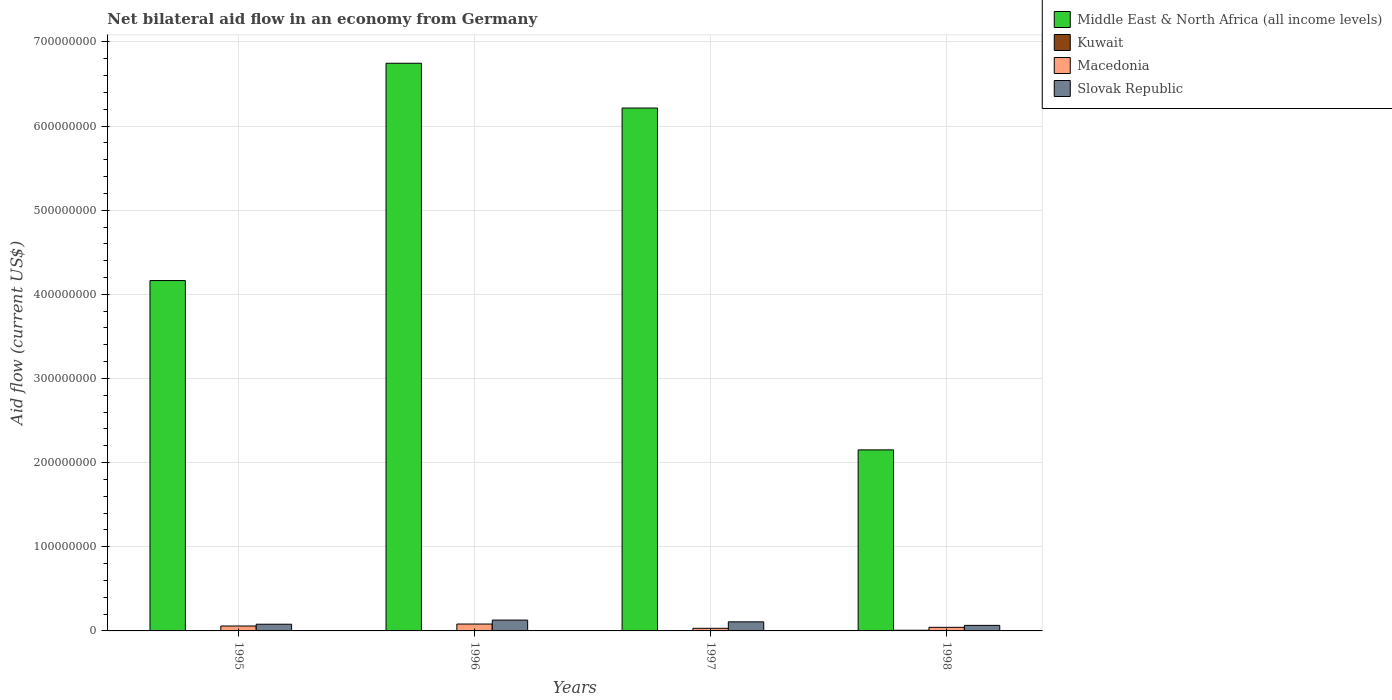Are the number of bars on each tick of the X-axis equal?
Make the answer very short. Yes. What is the net bilateral aid flow in Slovak Republic in 1998?
Offer a very short reply. 6.58e+06. Across all years, what is the maximum net bilateral aid flow in Slovak Republic?
Provide a succinct answer. 1.29e+07. Across all years, what is the minimum net bilateral aid flow in Middle East & North Africa (all income levels)?
Ensure brevity in your answer.  2.15e+08. What is the total net bilateral aid flow in Slovak Republic in the graph?
Your answer should be compact. 3.82e+07. What is the difference between the net bilateral aid flow in Middle East & North Africa (all income levels) in 1997 and that in 1998?
Offer a very short reply. 4.06e+08. What is the difference between the net bilateral aid flow in Macedonia in 1998 and the net bilateral aid flow in Middle East & North Africa (all income levels) in 1996?
Offer a terse response. -6.70e+08. What is the average net bilateral aid flow in Middle East & North Africa (all income levels) per year?
Provide a succinct answer. 4.82e+08. In the year 1997, what is the difference between the net bilateral aid flow in Kuwait and net bilateral aid flow in Middle East & North Africa (all income levels)?
Keep it short and to the point. -6.21e+08. In how many years, is the net bilateral aid flow in Middle East & North Africa (all income levels) greater than 120000000 US$?
Offer a terse response. 4. What is the ratio of the net bilateral aid flow in Kuwait in 1995 to that in 1997?
Your answer should be compact. 1.25. Is the difference between the net bilateral aid flow in Kuwait in 1995 and 1998 greater than the difference between the net bilateral aid flow in Middle East & North Africa (all income levels) in 1995 and 1998?
Give a very brief answer. No. What is the difference between the highest and the second highest net bilateral aid flow in Macedonia?
Provide a short and direct response. 2.31e+06. What is the difference between the highest and the lowest net bilateral aid flow in Middle East & North Africa (all income levels)?
Offer a terse response. 4.59e+08. What does the 1st bar from the left in 1998 represents?
Provide a succinct answer. Middle East & North Africa (all income levels). What does the 3rd bar from the right in 1995 represents?
Keep it short and to the point. Kuwait. Is it the case that in every year, the sum of the net bilateral aid flow in Middle East & North Africa (all income levels) and net bilateral aid flow in Kuwait is greater than the net bilateral aid flow in Slovak Republic?
Your answer should be very brief. Yes. How many years are there in the graph?
Offer a very short reply. 4. What is the difference between two consecutive major ticks on the Y-axis?
Provide a short and direct response. 1.00e+08. Are the values on the major ticks of Y-axis written in scientific E-notation?
Provide a short and direct response. No. How are the legend labels stacked?
Make the answer very short. Vertical. What is the title of the graph?
Your response must be concise. Net bilateral aid flow in an economy from Germany. What is the label or title of the X-axis?
Your response must be concise. Years. What is the label or title of the Y-axis?
Your answer should be compact. Aid flow (current US$). What is the Aid flow (current US$) of Middle East & North Africa (all income levels) in 1995?
Give a very brief answer. 4.16e+08. What is the Aid flow (current US$) of Kuwait in 1995?
Provide a short and direct response. 1.50e+05. What is the Aid flow (current US$) in Macedonia in 1995?
Provide a short and direct response. 5.86e+06. What is the Aid flow (current US$) of Slovak Republic in 1995?
Offer a very short reply. 7.96e+06. What is the Aid flow (current US$) in Middle East & North Africa (all income levels) in 1996?
Make the answer very short. 6.75e+08. What is the Aid flow (current US$) of Macedonia in 1996?
Offer a very short reply. 8.17e+06. What is the Aid flow (current US$) of Slovak Republic in 1996?
Provide a succinct answer. 1.29e+07. What is the Aid flow (current US$) of Middle East & North Africa (all income levels) in 1997?
Offer a very short reply. 6.21e+08. What is the Aid flow (current US$) in Macedonia in 1997?
Your response must be concise. 3.11e+06. What is the Aid flow (current US$) in Slovak Republic in 1997?
Make the answer very short. 1.08e+07. What is the Aid flow (current US$) of Middle East & North Africa (all income levels) in 1998?
Give a very brief answer. 2.15e+08. What is the Aid flow (current US$) of Macedonia in 1998?
Offer a very short reply. 4.27e+06. What is the Aid flow (current US$) in Slovak Republic in 1998?
Ensure brevity in your answer.  6.58e+06. Across all years, what is the maximum Aid flow (current US$) in Middle East & North Africa (all income levels)?
Make the answer very short. 6.75e+08. Across all years, what is the maximum Aid flow (current US$) in Macedonia?
Offer a very short reply. 8.17e+06. Across all years, what is the maximum Aid flow (current US$) of Slovak Republic?
Keep it short and to the point. 1.29e+07. Across all years, what is the minimum Aid flow (current US$) in Middle East & North Africa (all income levels)?
Offer a terse response. 2.15e+08. Across all years, what is the minimum Aid flow (current US$) in Macedonia?
Ensure brevity in your answer.  3.11e+06. Across all years, what is the minimum Aid flow (current US$) of Slovak Republic?
Provide a short and direct response. 6.58e+06. What is the total Aid flow (current US$) of Middle East & North Africa (all income levels) in the graph?
Ensure brevity in your answer.  1.93e+09. What is the total Aid flow (current US$) in Kuwait in the graph?
Your answer should be very brief. 1.21e+06. What is the total Aid flow (current US$) of Macedonia in the graph?
Provide a short and direct response. 2.14e+07. What is the total Aid flow (current US$) in Slovak Republic in the graph?
Your response must be concise. 3.82e+07. What is the difference between the Aid flow (current US$) of Middle East & North Africa (all income levels) in 1995 and that in 1996?
Your answer should be very brief. -2.58e+08. What is the difference between the Aid flow (current US$) in Macedonia in 1995 and that in 1996?
Your response must be concise. -2.31e+06. What is the difference between the Aid flow (current US$) of Slovak Republic in 1995 and that in 1996?
Provide a succinct answer. -4.92e+06. What is the difference between the Aid flow (current US$) of Middle East & North Africa (all income levels) in 1995 and that in 1997?
Keep it short and to the point. -2.05e+08. What is the difference between the Aid flow (current US$) in Kuwait in 1995 and that in 1997?
Provide a short and direct response. 3.00e+04. What is the difference between the Aid flow (current US$) in Macedonia in 1995 and that in 1997?
Provide a succinct answer. 2.75e+06. What is the difference between the Aid flow (current US$) of Slovak Republic in 1995 and that in 1997?
Offer a terse response. -2.84e+06. What is the difference between the Aid flow (current US$) in Middle East & North Africa (all income levels) in 1995 and that in 1998?
Your response must be concise. 2.01e+08. What is the difference between the Aid flow (current US$) in Kuwait in 1995 and that in 1998?
Offer a terse response. -6.50e+05. What is the difference between the Aid flow (current US$) in Macedonia in 1995 and that in 1998?
Offer a terse response. 1.59e+06. What is the difference between the Aid flow (current US$) in Slovak Republic in 1995 and that in 1998?
Give a very brief answer. 1.38e+06. What is the difference between the Aid flow (current US$) in Middle East & North Africa (all income levels) in 1996 and that in 1997?
Provide a short and direct response. 5.32e+07. What is the difference between the Aid flow (current US$) in Macedonia in 1996 and that in 1997?
Make the answer very short. 5.06e+06. What is the difference between the Aid flow (current US$) in Slovak Republic in 1996 and that in 1997?
Your response must be concise. 2.08e+06. What is the difference between the Aid flow (current US$) of Middle East & North Africa (all income levels) in 1996 and that in 1998?
Your answer should be very brief. 4.59e+08. What is the difference between the Aid flow (current US$) in Kuwait in 1996 and that in 1998?
Offer a very short reply. -6.60e+05. What is the difference between the Aid flow (current US$) of Macedonia in 1996 and that in 1998?
Make the answer very short. 3.90e+06. What is the difference between the Aid flow (current US$) of Slovak Republic in 1996 and that in 1998?
Your answer should be compact. 6.30e+06. What is the difference between the Aid flow (current US$) of Middle East & North Africa (all income levels) in 1997 and that in 1998?
Your answer should be very brief. 4.06e+08. What is the difference between the Aid flow (current US$) in Kuwait in 1997 and that in 1998?
Provide a succinct answer. -6.80e+05. What is the difference between the Aid flow (current US$) in Macedonia in 1997 and that in 1998?
Offer a terse response. -1.16e+06. What is the difference between the Aid flow (current US$) in Slovak Republic in 1997 and that in 1998?
Ensure brevity in your answer.  4.22e+06. What is the difference between the Aid flow (current US$) in Middle East & North Africa (all income levels) in 1995 and the Aid flow (current US$) in Kuwait in 1996?
Provide a short and direct response. 4.16e+08. What is the difference between the Aid flow (current US$) in Middle East & North Africa (all income levels) in 1995 and the Aid flow (current US$) in Macedonia in 1996?
Provide a short and direct response. 4.08e+08. What is the difference between the Aid flow (current US$) of Middle East & North Africa (all income levels) in 1995 and the Aid flow (current US$) of Slovak Republic in 1996?
Your answer should be compact. 4.03e+08. What is the difference between the Aid flow (current US$) of Kuwait in 1995 and the Aid flow (current US$) of Macedonia in 1996?
Make the answer very short. -8.02e+06. What is the difference between the Aid flow (current US$) in Kuwait in 1995 and the Aid flow (current US$) in Slovak Republic in 1996?
Provide a succinct answer. -1.27e+07. What is the difference between the Aid flow (current US$) in Macedonia in 1995 and the Aid flow (current US$) in Slovak Republic in 1996?
Your response must be concise. -7.02e+06. What is the difference between the Aid flow (current US$) of Middle East & North Africa (all income levels) in 1995 and the Aid flow (current US$) of Kuwait in 1997?
Your answer should be very brief. 4.16e+08. What is the difference between the Aid flow (current US$) in Middle East & North Africa (all income levels) in 1995 and the Aid flow (current US$) in Macedonia in 1997?
Your answer should be very brief. 4.13e+08. What is the difference between the Aid flow (current US$) in Middle East & North Africa (all income levels) in 1995 and the Aid flow (current US$) in Slovak Republic in 1997?
Your response must be concise. 4.06e+08. What is the difference between the Aid flow (current US$) of Kuwait in 1995 and the Aid flow (current US$) of Macedonia in 1997?
Your answer should be very brief. -2.96e+06. What is the difference between the Aid flow (current US$) in Kuwait in 1995 and the Aid flow (current US$) in Slovak Republic in 1997?
Provide a short and direct response. -1.06e+07. What is the difference between the Aid flow (current US$) of Macedonia in 1995 and the Aid flow (current US$) of Slovak Republic in 1997?
Your response must be concise. -4.94e+06. What is the difference between the Aid flow (current US$) in Middle East & North Africa (all income levels) in 1995 and the Aid flow (current US$) in Kuwait in 1998?
Your answer should be very brief. 4.16e+08. What is the difference between the Aid flow (current US$) in Middle East & North Africa (all income levels) in 1995 and the Aid flow (current US$) in Macedonia in 1998?
Your answer should be compact. 4.12e+08. What is the difference between the Aid flow (current US$) in Middle East & North Africa (all income levels) in 1995 and the Aid flow (current US$) in Slovak Republic in 1998?
Provide a succinct answer. 4.10e+08. What is the difference between the Aid flow (current US$) in Kuwait in 1995 and the Aid flow (current US$) in Macedonia in 1998?
Ensure brevity in your answer.  -4.12e+06. What is the difference between the Aid flow (current US$) of Kuwait in 1995 and the Aid flow (current US$) of Slovak Republic in 1998?
Keep it short and to the point. -6.43e+06. What is the difference between the Aid flow (current US$) of Macedonia in 1995 and the Aid flow (current US$) of Slovak Republic in 1998?
Provide a short and direct response. -7.20e+05. What is the difference between the Aid flow (current US$) in Middle East & North Africa (all income levels) in 1996 and the Aid flow (current US$) in Kuwait in 1997?
Ensure brevity in your answer.  6.74e+08. What is the difference between the Aid flow (current US$) in Middle East & North Africa (all income levels) in 1996 and the Aid flow (current US$) in Macedonia in 1997?
Your answer should be very brief. 6.71e+08. What is the difference between the Aid flow (current US$) in Middle East & North Africa (all income levels) in 1996 and the Aid flow (current US$) in Slovak Republic in 1997?
Your answer should be compact. 6.64e+08. What is the difference between the Aid flow (current US$) in Kuwait in 1996 and the Aid flow (current US$) in Macedonia in 1997?
Your answer should be compact. -2.97e+06. What is the difference between the Aid flow (current US$) of Kuwait in 1996 and the Aid flow (current US$) of Slovak Republic in 1997?
Your response must be concise. -1.07e+07. What is the difference between the Aid flow (current US$) of Macedonia in 1996 and the Aid flow (current US$) of Slovak Republic in 1997?
Your response must be concise. -2.63e+06. What is the difference between the Aid flow (current US$) of Middle East & North Africa (all income levels) in 1996 and the Aid flow (current US$) of Kuwait in 1998?
Your answer should be very brief. 6.74e+08. What is the difference between the Aid flow (current US$) in Middle East & North Africa (all income levels) in 1996 and the Aid flow (current US$) in Macedonia in 1998?
Your answer should be compact. 6.70e+08. What is the difference between the Aid flow (current US$) of Middle East & North Africa (all income levels) in 1996 and the Aid flow (current US$) of Slovak Republic in 1998?
Your answer should be compact. 6.68e+08. What is the difference between the Aid flow (current US$) in Kuwait in 1996 and the Aid flow (current US$) in Macedonia in 1998?
Your answer should be compact. -4.13e+06. What is the difference between the Aid flow (current US$) of Kuwait in 1996 and the Aid flow (current US$) of Slovak Republic in 1998?
Ensure brevity in your answer.  -6.44e+06. What is the difference between the Aid flow (current US$) in Macedonia in 1996 and the Aid flow (current US$) in Slovak Republic in 1998?
Make the answer very short. 1.59e+06. What is the difference between the Aid flow (current US$) of Middle East & North Africa (all income levels) in 1997 and the Aid flow (current US$) of Kuwait in 1998?
Your answer should be compact. 6.21e+08. What is the difference between the Aid flow (current US$) in Middle East & North Africa (all income levels) in 1997 and the Aid flow (current US$) in Macedonia in 1998?
Offer a very short reply. 6.17e+08. What is the difference between the Aid flow (current US$) of Middle East & North Africa (all income levels) in 1997 and the Aid flow (current US$) of Slovak Republic in 1998?
Your answer should be compact. 6.15e+08. What is the difference between the Aid flow (current US$) of Kuwait in 1997 and the Aid flow (current US$) of Macedonia in 1998?
Keep it short and to the point. -4.15e+06. What is the difference between the Aid flow (current US$) of Kuwait in 1997 and the Aid flow (current US$) of Slovak Republic in 1998?
Offer a very short reply. -6.46e+06. What is the difference between the Aid flow (current US$) in Macedonia in 1997 and the Aid flow (current US$) in Slovak Republic in 1998?
Keep it short and to the point. -3.47e+06. What is the average Aid flow (current US$) in Middle East & North Africa (all income levels) per year?
Your response must be concise. 4.82e+08. What is the average Aid flow (current US$) in Kuwait per year?
Offer a very short reply. 3.02e+05. What is the average Aid flow (current US$) in Macedonia per year?
Provide a succinct answer. 5.35e+06. What is the average Aid flow (current US$) in Slovak Republic per year?
Make the answer very short. 9.56e+06. In the year 1995, what is the difference between the Aid flow (current US$) in Middle East & North Africa (all income levels) and Aid flow (current US$) in Kuwait?
Provide a short and direct response. 4.16e+08. In the year 1995, what is the difference between the Aid flow (current US$) in Middle East & North Africa (all income levels) and Aid flow (current US$) in Macedonia?
Give a very brief answer. 4.10e+08. In the year 1995, what is the difference between the Aid flow (current US$) in Middle East & North Africa (all income levels) and Aid flow (current US$) in Slovak Republic?
Offer a terse response. 4.08e+08. In the year 1995, what is the difference between the Aid flow (current US$) in Kuwait and Aid flow (current US$) in Macedonia?
Offer a terse response. -5.71e+06. In the year 1995, what is the difference between the Aid flow (current US$) in Kuwait and Aid flow (current US$) in Slovak Republic?
Provide a succinct answer. -7.81e+06. In the year 1995, what is the difference between the Aid flow (current US$) in Macedonia and Aid flow (current US$) in Slovak Republic?
Provide a short and direct response. -2.10e+06. In the year 1996, what is the difference between the Aid flow (current US$) of Middle East & North Africa (all income levels) and Aid flow (current US$) of Kuwait?
Ensure brevity in your answer.  6.74e+08. In the year 1996, what is the difference between the Aid flow (current US$) of Middle East & North Africa (all income levels) and Aid flow (current US$) of Macedonia?
Give a very brief answer. 6.66e+08. In the year 1996, what is the difference between the Aid flow (current US$) in Middle East & North Africa (all income levels) and Aid flow (current US$) in Slovak Republic?
Provide a short and direct response. 6.62e+08. In the year 1996, what is the difference between the Aid flow (current US$) of Kuwait and Aid flow (current US$) of Macedonia?
Your answer should be very brief. -8.03e+06. In the year 1996, what is the difference between the Aid flow (current US$) in Kuwait and Aid flow (current US$) in Slovak Republic?
Give a very brief answer. -1.27e+07. In the year 1996, what is the difference between the Aid flow (current US$) of Macedonia and Aid flow (current US$) of Slovak Republic?
Provide a short and direct response. -4.71e+06. In the year 1997, what is the difference between the Aid flow (current US$) of Middle East & North Africa (all income levels) and Aid flow (current US$) of Kuwait?
Your answer should be very brief. 6.21e+08. In the year 1997, what is the difference between the Aid flow (current US$) in Middle East & North Africa (all income levels) and Aid flow (current US$) in Macedonia?
Provide a short and direct response. 6.18e+08. In the year 1997, what is the difference between the Aid flow (current US$) in Middle East & North Africa (all income levels) and Aid flow (current US$) in Slovak Republic?
Your answer should be very brief. 6.11e+08. In the year 1997, what is the difference between the Aid flow (current US$) in Kuwait and Aid flow (current US$) in Macedonia?
Provide a short and direct response. -2.99e+06. In the year 1997, what is the difference between the Aid flow (current US$) in Kuwait and Aid flow (current US$) in Slovak Republic?
Make the answer very short. -1.07e+07. In the year 1997, what is the difference between the Aid flow (current US$) in Macedonia and Aid flow (current US$) in Slovak Republic?
Your answer should be very brief. -7.69e+06. In the year 1998, what is the difference between the Aid flow (current US$) in Middle East & North Africa (all income levels) and Aid flow (current US$) in Kuwait?
Your answer should be very brief. 2.14e+08. In the year 1998, what is the difference between the Aid flow (current US$) of Middle East & North Africa (all income levels) and Aid flow (current US$) of Macedonia?
Keep it short and to the point. 2.11e+08. In the year 1998, what is the difference between the Aid flow (current US$) in Middle East & North Africa (all income levels) and Aid flow (current US$) in Slovak Republic?
Give a very brief answer. 2.09e+08. In the year 1998, what is the difference between the Aid flow (current US$) of Kuwait and Aid flow (current US$) of Macedonia?
Keep it short and to the point. -3.47e+06. In the year 1998, what is the difference between the Aid flow (current US$) in Kuwait and Aid flow (current US$) in Slovak Republic?
Give a very brief answer. -5.78e+06. In the year 1998, what is the difference between the Aid flow (current US$) of Macedonia and Aid flow (current US$) of Slovak Republic?
Offer a very short reply. -2.31e+06. What is the ratio of the Aid flow (current US$) in Middle East & North Africa (all income levels) in 1995 to that in 1996?
Provide a succinct answer. 0.62. What is the ratio of the Aid flow (current US$) of Kuwait in 1995 to that in 1996?
Make the answer very short. 1.07. What is the ratio of the Aid flow (current US$) in Macedonia in 1995 to that in 1996?
Give a very brief answer. 0.72. What is the ratio of the Aid flow (current US$) of Slovak Republic in 1995 to that in 1996?
Make the answer very short. 0.62. What is the ratio of the Aid flow (current US$) in Middle East & North Africa (all income levels) in 1995 to that in 1997?
Make the answer very short. 0.67. What is the ratio of the Aid flow (current US$) in Kuwait in 1995 to that in 1997?
Keep it short and to the point. 1.25. What is the ratio of the Aid flow (current US$) of Macedonia in 1995 to that in 1997?
Keep it short and to the point. 1.88. What is the ratio of the Aid flow (current US$) of Slovak Republic in 1995 to that in 1997?
Make the answer very short. 0.74. What is the ratio of the Aid flow (current US$) in Middle East & North Africa (all income levels) in 1995 to that in 1998?
Make the answer very short. 1.94. What is the ratio of the Aid flow (current US$) in Kuwait in 1995 to that in 1998?
Your answer should be very brief. 0.19. What is the ratio of the Aid flow (current US$) in Macedonia in 1995 to that in 1998?
Give a very brief answer. 1.37. What is the ratio of the Aid flow (current US$) of Slovak Republic in 1995 to that in 1998?
Offer a very short reply. 1.21. What is the ratio of the Aid flow (current US$) in Middle East & North Africa (all income levels) in 1996 to that in 1997?
Offer a terse response. 1.09. What is the ratio of the Aid flow (current US$) of Macedonia in 1996 to that in 1997?
Give a very brief answer. 2.63. What is the ratio of the Aid flow (current US$) in Slovak Republic in 1996 to that in 1997?
Offer a terse response. 1.19. What is the ratio of the Aid flow (current US$) of Middle East & North Africa (all income levels) in 1996 to that in 1998?
Make the answer very short. 3.14. What is the ratio of the Aid flow (current US$) in Kuwait in 1996 to that in 1998?
Keep it short and to the point. 0.17. What is the ratio of the Aid flow (current US$) in Macedonia in 1996 to that in 1998?
Make the answer very short. 1.91. What is the ratio of the Aid flow (current US$) of Slovak Republic in 1996 to that in 1998?
Provide a short and direct response. 1.96. What is the ratio of the Aid flow (current US$) in Middle East & North Africa (all income levels) in 1997 to that in 1998?
Offer a terse response. 2.89. What is the ratio of the Aid flow (current US$) of Kuwait in 1997 to that in 1998?
Keep it short and to the point. 0.15. What is the ratio of the Aid flow (current US$) of Macedonia in 1997 to that in 1998?
Make the answer very short. 0.73. What is the ratio of the Aid flow (current US$) in Slovak Republic in 1997 to that in 1998?
Offer a terse response. 1.64. What is the difference between the highest and the second highest Aid flow (current US$) in Middle East & North Africa (all income levels)?
Make the answer very short. 5.32e+07. What is the difference between the highest and the second highest Aid flow (current US$) in Kuwait?
Your answer should be compact. 6.50e+05. What is the difference between the highest and the second highest Aid flow (current US$) of Macedonia?
Make the answer very short. 2.31e+06. What is the difference between the highest and the second highest Aid flow (current US$) in Slovak Republic?
Your answer should be very brief. 2.08e+06. What is the difference between the highest and the lowest Aid flow (current US$) of Middle East & North Africa (all income levels)?
Offer a terse response. 4.59e+08. What is the difference between the highest and the lowest Aid flow (current US$) in Kuwait?
Offer a terse response. 6.80e+05. What is the difference between the highest and the lowest Aid flow (current US$) in Macedonia?
Your response must be concise. 5.06e+06. What is the difference between the highest and the lowest Aid flow (current US$) of Slovak Republic?
Keep it short and to the point. 6.30e+06. 